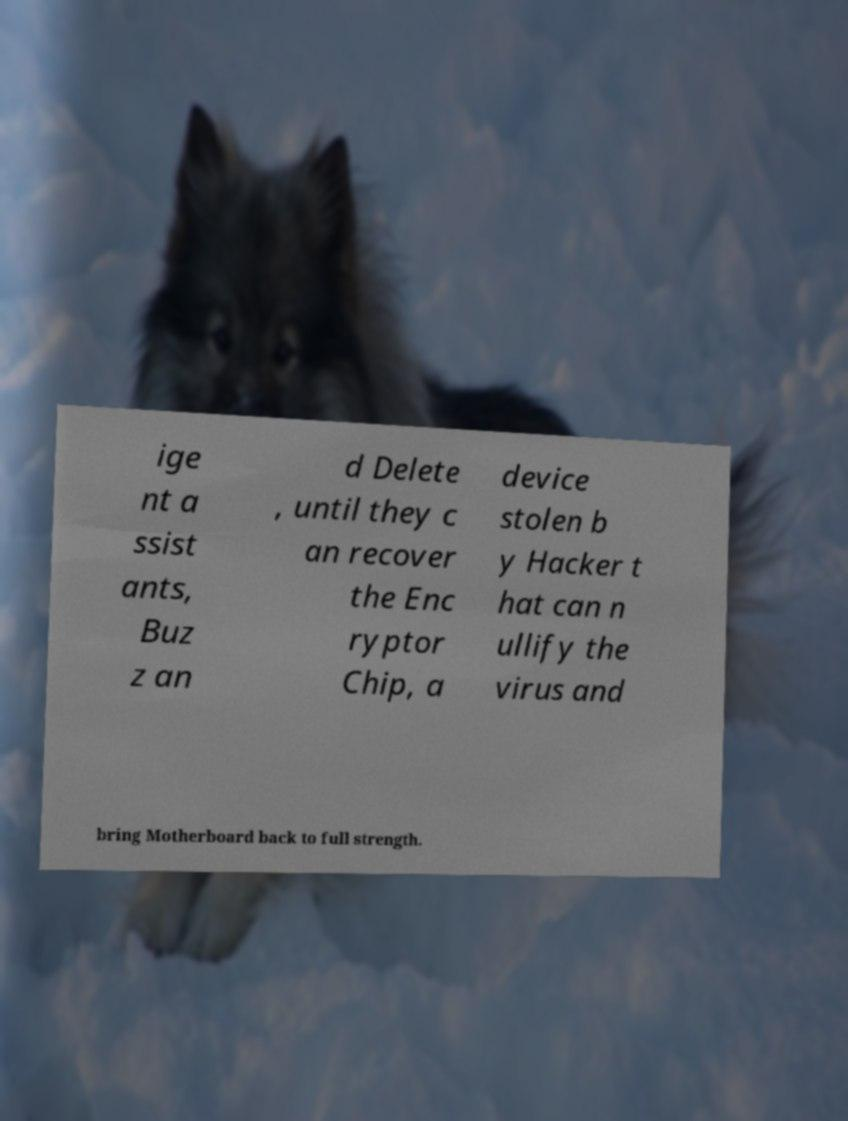Can you accurately transcribe the text from the provided image for me? ige nt a ssist ants, Buz z an d Delete , until they c an recover the Enc ryptor Chip, a device stolen b y Hacker t hat can n ullify the virus and bring Motherboard back to full strength. 